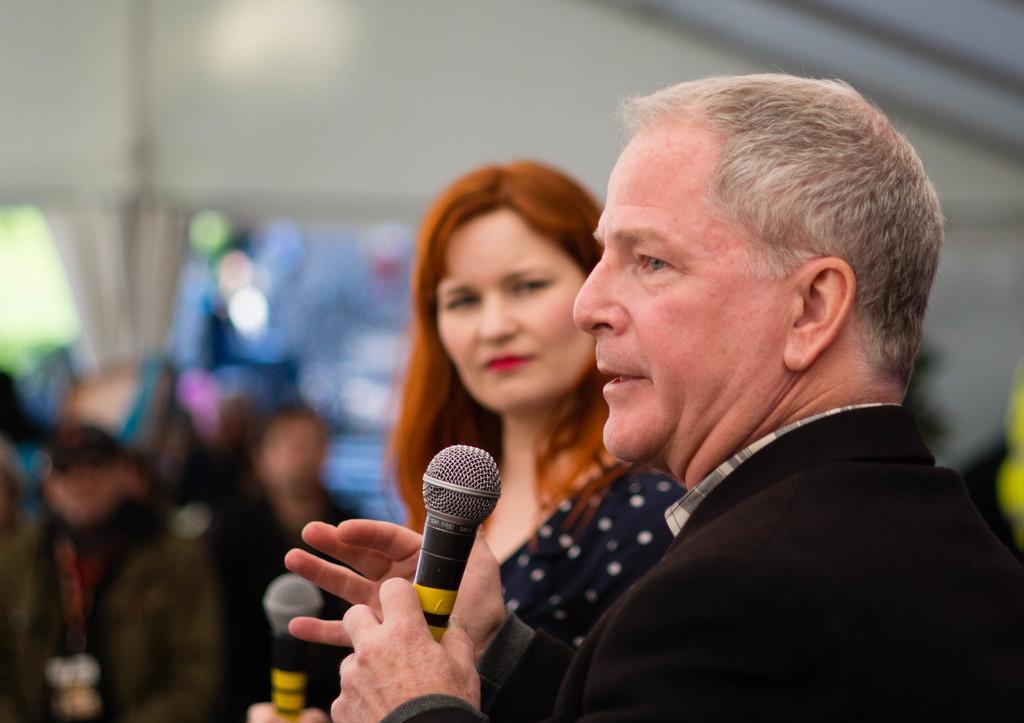Describe this image in one or two sentences. In this picture,a man is speaking with a mic in his hand. Beside him a woman is watching. 